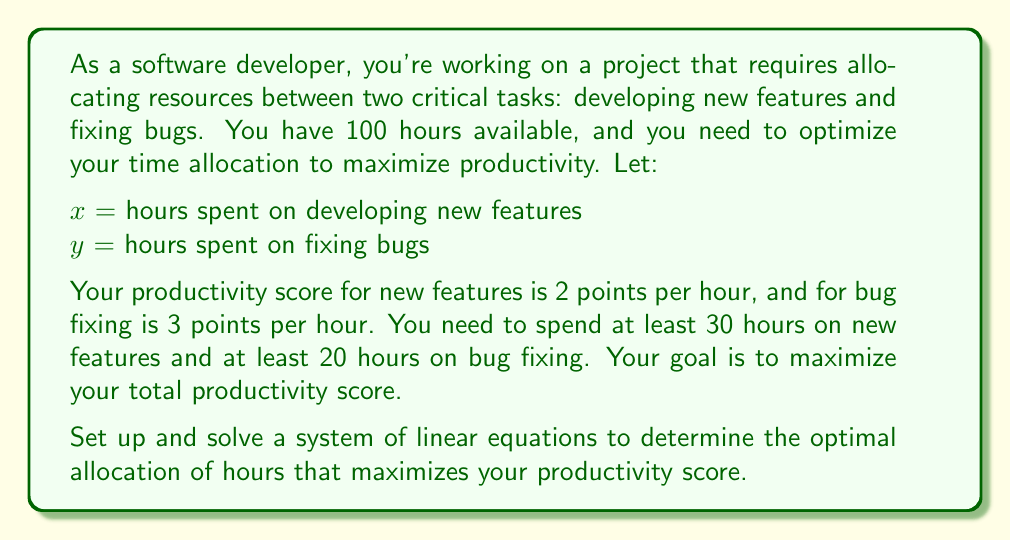Can you answer this question? To solve this problem, we'll follow these steps:

1. Set up the objective function
2. Identify the constraints
3. Create a system of linear equations
4. Solve the system using substitution or elimination
5. Interpret the results

Step 1: Set up the objective function
The productivity score (P) is calculated as:
$$P = 2x + 3y$$

We want to maximize this function.

Step 2: Identify the constraints
- Total available time: $x + y = 100$
- Minimum time for new features: $x \geq 30$
- Minimum time for bug fixing: $y \geq 20$

Step 3: Create a system of linear equations
We'll use the total available time constraint and the objective function:
$$x + y = 100$$
$$P = 2x + 3y$$

Step 4: Solve the system
We can use substitution to solve this system. From the first equation:
$$y = 100 - x$$

Substitute this into the productivity function:
$$P = 2x + 3(100 - x)$$
$$P = 2x + 300 - 3x$$
$$P = 300 - x$$

To maximize P, we need to minimize x. However, we have the constraint that $x \geq 30$.

Therefore, the optimal solution is:
$$x = 30$$
$$y = 100 - 30 = 70$$

Step 5: Interpret the results
The optimal allocation is 30 hours for developing new features and 70 hours for fixing bugs. This satisfies all constraints and maximizes the productivity score.

To calculate the maximum productivity score:
$$P = 2(30) + 3(70) = 60 + 210 = 270$$
Answer: The optimal allocation is 30 hours for developing new features and 70 hours for fixing bugs, resulting in a maximum productivity score of 270 points. 